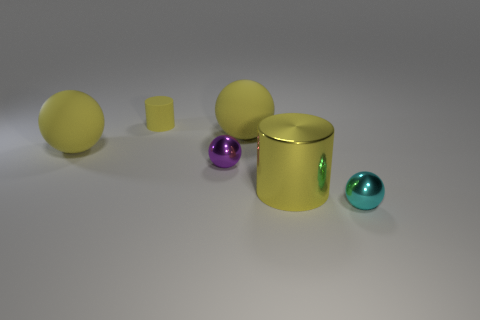Are there any tiny red cubes?
Provide a succinct answer. No. Is the small yellow thing the same shape as the purple shiny thing?
Your answer should be very brief. No. There is a large sphere behind the yellow matte ball that is left of the tiny rubber thing; how many small balls are behind it?
Your answer should be compact. 0. There is a tiny thing that is both in front of the small matte cylinder and on the left side of the large yellow cylinder; what material is it made of?
Give a very brief answer. Metal. There is a thing that is both to the right of the tiny purple metallic ball and behind the big yellow metallic object; what is its color?
Provide a short and direct response. Yellow. Is there anything else of the same color as the tiny cylinder?
Provide a succinct answer. Yes. The small thing that is behind the large yellow sphere in front of the big rubber object right of the tiny purple metal object is what shape?
Your response must be concise. Cylinder. The other small object that is the same shape as the small cyan shiny object is what color?
Offer a very short reply. Purple. What color is the tiny ball in front of the shiny ball that is on the left side of the small cyan shiny ball?
Give a very brief answer. Cyan. There is another metallic object that is the same shape as the tiny cyan metal thing; what size is it?
Offer a very short reply. Small. 